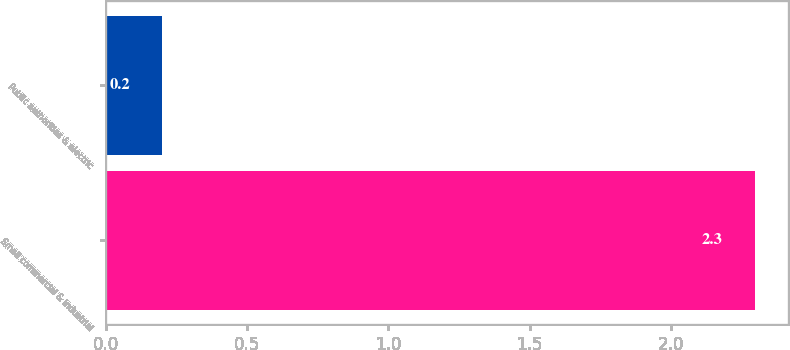Convert chart to OTSL. <chart><loc_0><loc_0><loc_500><loc_500><bar_chart><fcel>Small commercial & industrial<fcel>Public authorities & electric<nl><fcel>2.3<fcel>0.2<nl></chart> 